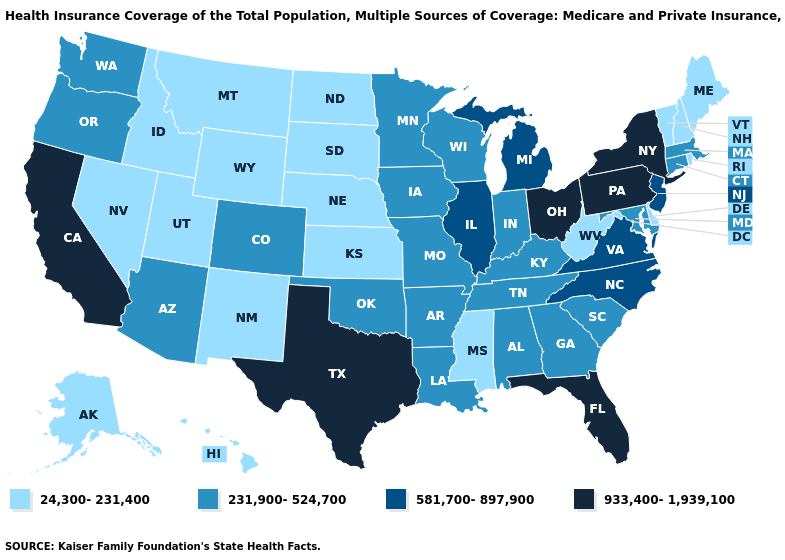Name the states that have a value in the range 231,900-524,700?
Write a very short answer. Alabama, Arizona, Arkansas, Colorado, Connecticut, Georgia, Indiana, Iowa, Kentucky, Louisiana, Maryland, Massachusetts, Minnesota, Missouri, Oklahoma, Oregon, South Carolina, Tennessee, Washington, Wisconsin. Name the states that have a value in the range 24,300-231,400?
Be succinct. Alaska, Delaware, Hawaii, Idaho, Kansas, Maine, Mississippi, Montana, Nebraska, Nevada, New Hampshire, New Mexico, North Dakota, Rhode Island, South Dakota, Utah, Vermont, West Virginia, Wyoming. Does Texas have the highest value in the South?
Give a very brief answer. Yes. Which states have the lowest value in the MidWest?
Concise answer only. Kansas, Nebraska, North Dakota, South Dakota. Among the states that border Washington , which have the highest value?
Quick response, please. Oregon. Which states hav the highest value in the West?
Write a very short answer. California. Name the states that have a value in the range 581,700-897,900?
Short answer required. Illinois, Michigan, New Jersey, North Carolina, Virginia. Does the map have missing data?
Answer briefly. No. What is the lowest value in the USA?
Quick response, please. 24,300-231,400. Does Indiana have the lowest value in the USA?
Give a very brief answer. No. Among the states that border Maryland , which have the lowest value?
Keep it brief. Delaware, West Virginia. What is the lowest value in the Northeast?
Be succinct. 24,300-231,400. Name the states that have a value in the range 933,400-1,939,100?
Concise answer only. California, Florida, New York, Ohio, Pennsylvania, Texas. What is the lowest value in states that border Maine?
Keep it brief. 24,300-231,400. 